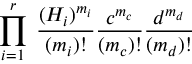Convert formula to latex. <formula><loc_0><loc_0><loc_500><loc_500>\prod _ { i = 1 } ^ { r } \, \frac { ( H _ { i } ) ^ { m _ { i } } } { ( m _ { i } ) ! } \frac { c ^ { m _ { c } } } { ( m _ { c } ) ! } \frac { d ^ { m _ { d } } } { ( m _ { d } ) ! }</formula> 